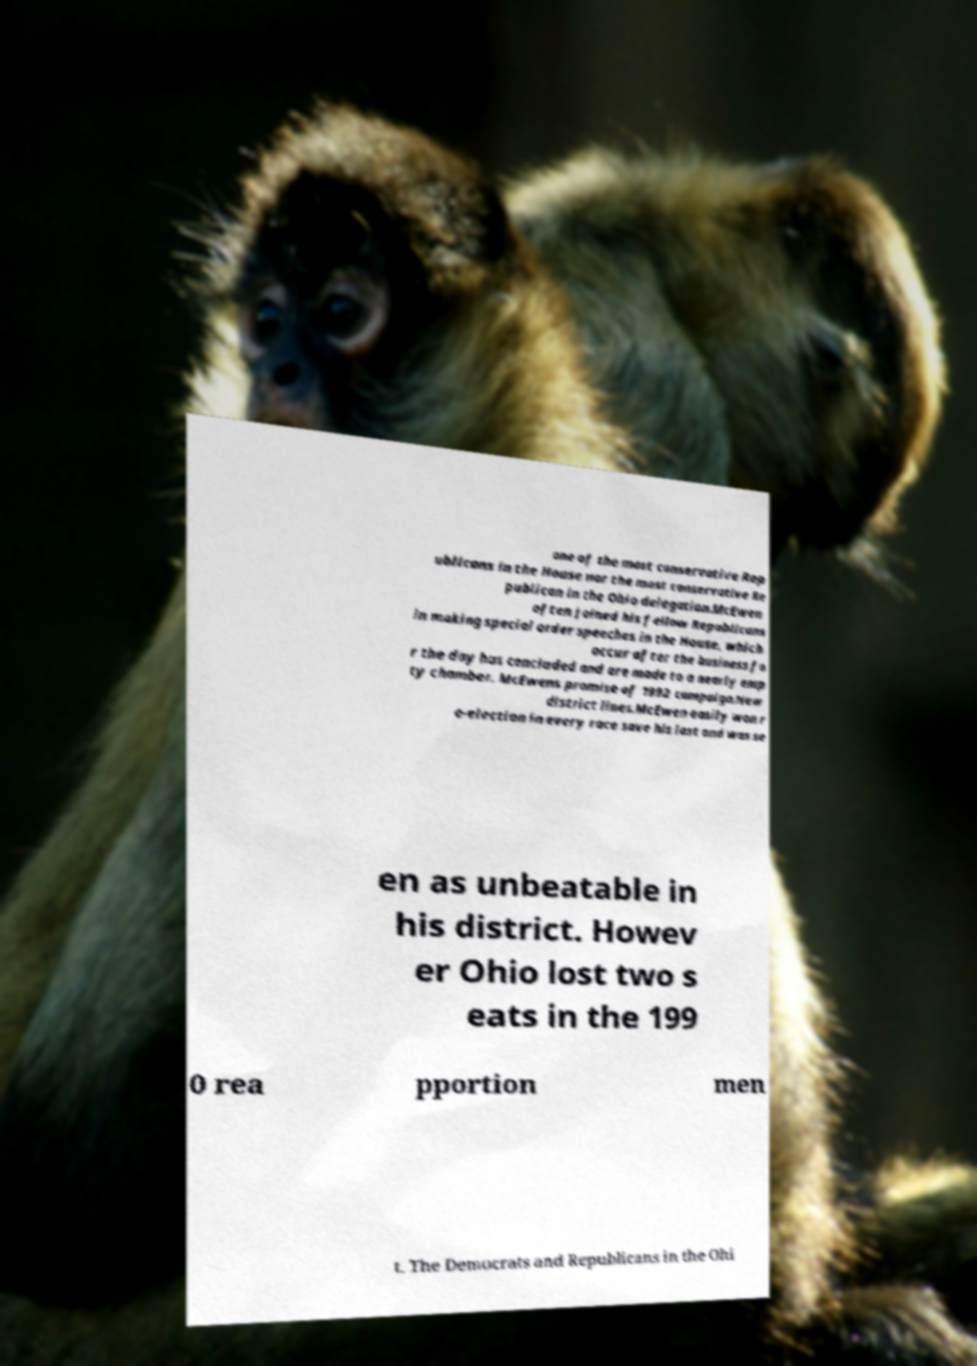There's text embedded in this image that I need extracted. Can you transcribe it verbatim? one of the most conservative Rep ublicans in the House nor the most conservative Re publican in the Ohio delegation.McEwen often joined his fellow Republicans in making special order speeches in the House, which occur after the business fo r the day has concluded and are made to a nearly emp ty chamber. McEwens promise of 1992 campaign.New district lines.McEwen easily won r e-election in every race save his last and was se en as unbeatable in his district. Howev er Ohio lost two s eats in the 199 0 rea pportion men t. The Democrats and Republicans in the Ohi 